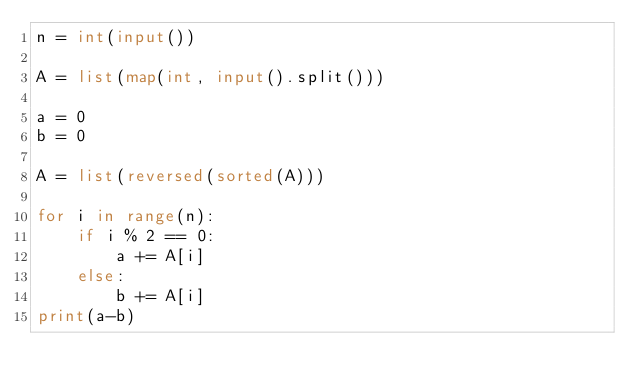<code> <loc_0><loc_0><loc_500><loc_500><_Python_>n = int(input())

A = list(map(int, input().split()))

a = 0
b = 0

A = list(reversed(sorted(A)))

for i in range(n):
    if i % 2 == 0:
        a += A[i]
    else:
        b += A[i]
print(a-b)</code> 